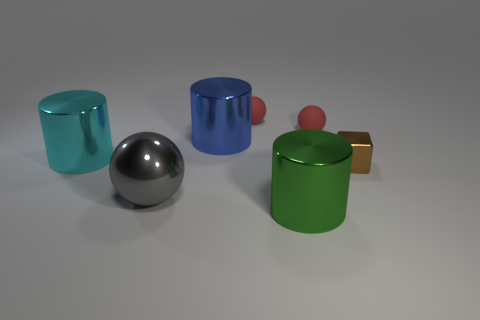Subtract all brown spheres. Subtract all gray cylinders. How many spheres are left? 3 Add 2 blue objects. How many objects exist? 9 Subtract all balls. How many objects are left? 4 Add 1 large green metal cylinders. How many large green metal cylinders are left? 2 Add 2 gray metal cubes. How many gray metal cubes exist? 2 Subtract 0 purple cylinders. How many objects are left? 7 Subtract all blue rubber cylinders. Subtract all cylinders. How many objects are left? 4 